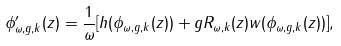Convert formula to latex. <formula><loc_0><loc_0><loc_500><loc_500>\phi _ { \omega , g , k } ^ { \prime } ( z ) = \frac { 1 } { \omega } [ h ( \phi _ { \omega , g , k } ( z ) ) + g R _ { \omega , k } ( z ) w ( \phi _ { \omega , g , k } ( z ) ) ] ,</formula> 